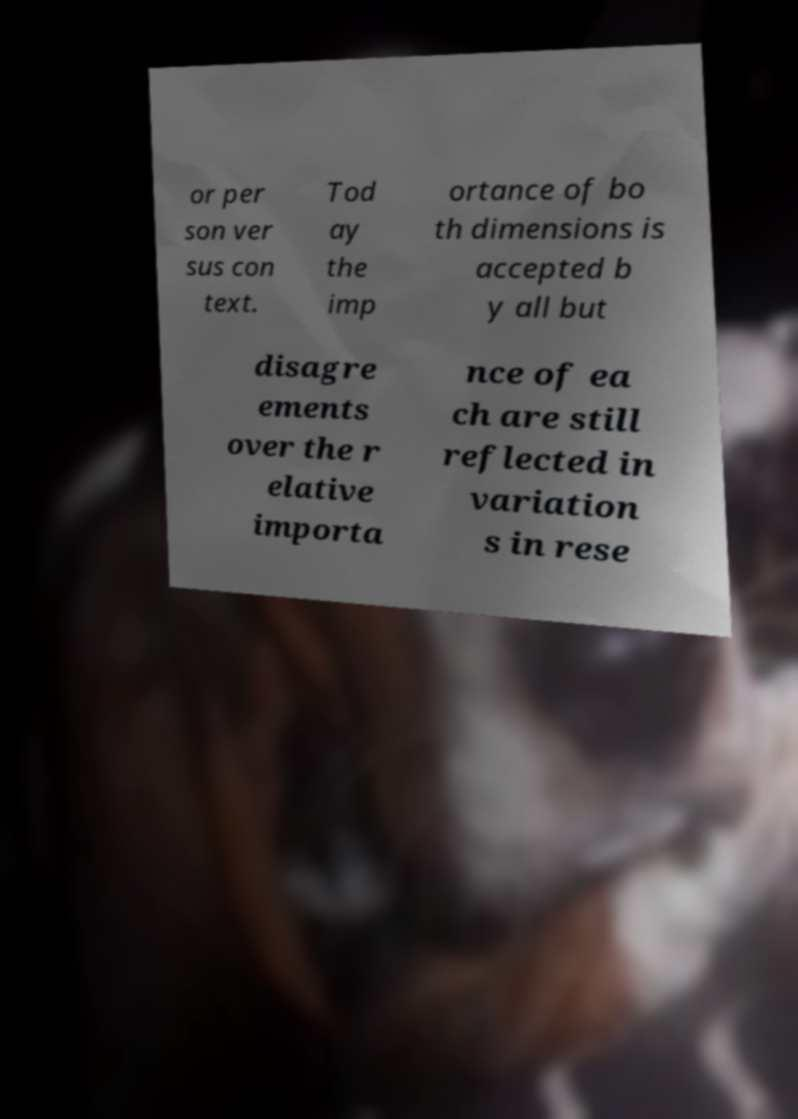What messages or text are displayed in this image? I need them in a readable, typed format. or per son ver sus con text. Tod ay the imp ortance of bo th dimensions is accepted b y all but disagre ements over the r elative importa nce of ea ch are still reflected in variation s in rese 